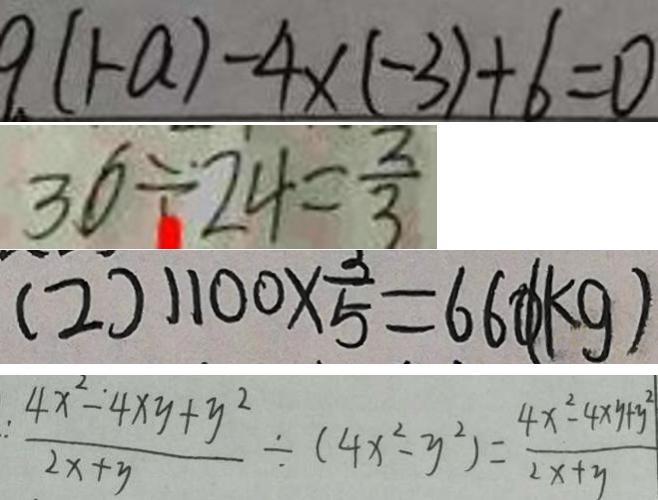Convert formula to latex. <formula><loc_0><loc_0><loc_500><loc_500>9 ( 1 - a ) - 4 \times ( - 3 ) + 6 = 0 
 3 6 \div 2 4 = \frac { 2 } { 3 } 
 ( 2 ) 1 1 0 0 \times \frac { 3 } { 5 } = 6 6 0 ( k g ) 
 \frac { 4 x ^ { 2 } - 4 x y + y ^ { 2 } } { 2 x + y } \div ( 4 x ^ { 2 } - y ^ { 2 } ) = \frac { 4 x ^ { 2 } - 4 x y + y ^ { 2 } } { 2 x + y }</formula> 